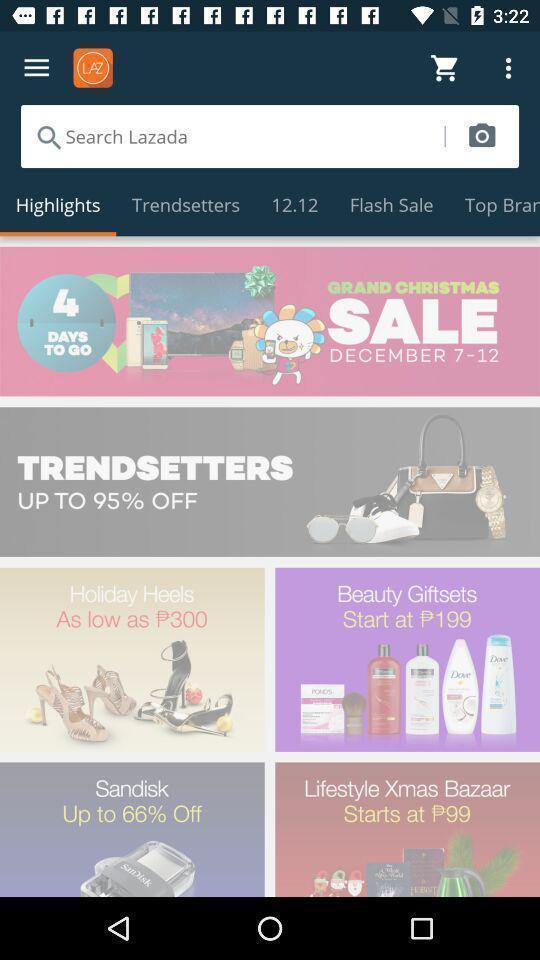Explain what's happening in this screen capture. Search page to find multiple items for online shopping. 